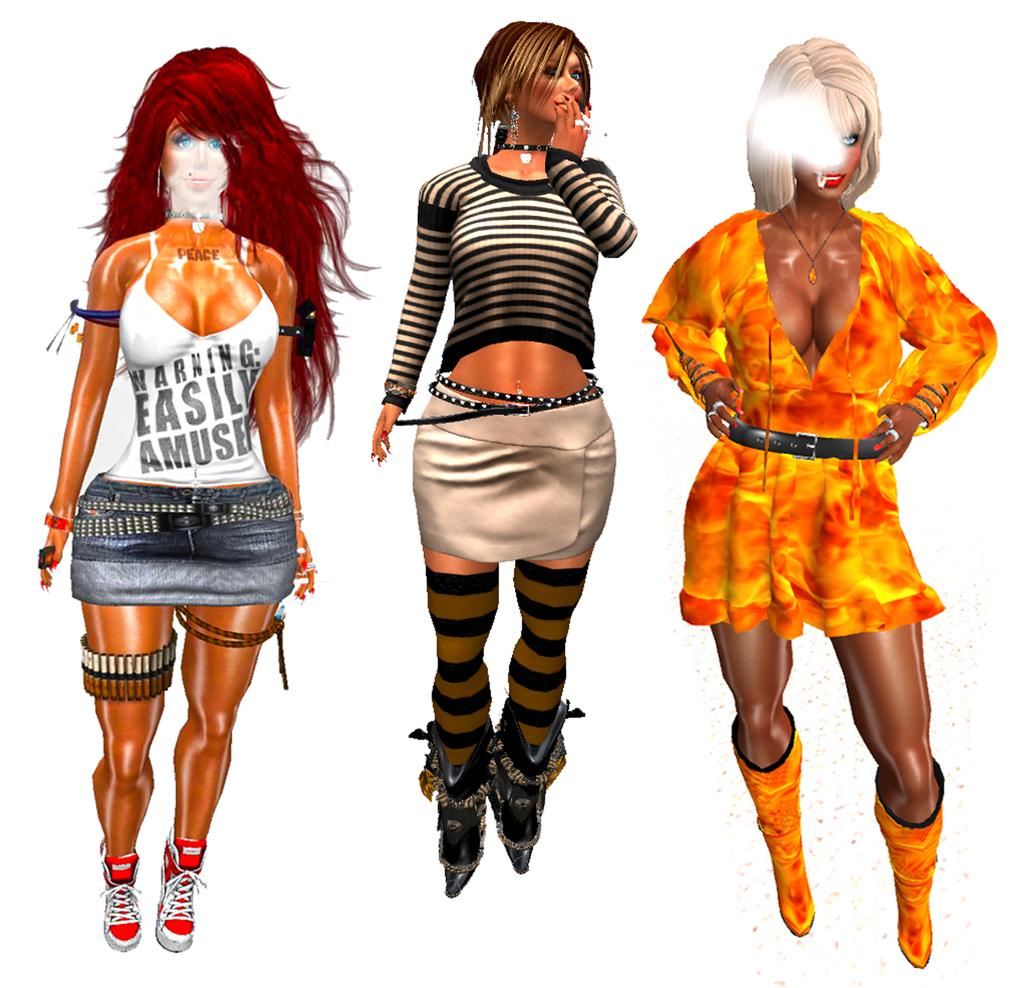<image>
Summarize the visual content of the image. Images of three women including one wearing a white shirt reading WARNING: EASILY AMUSED. 